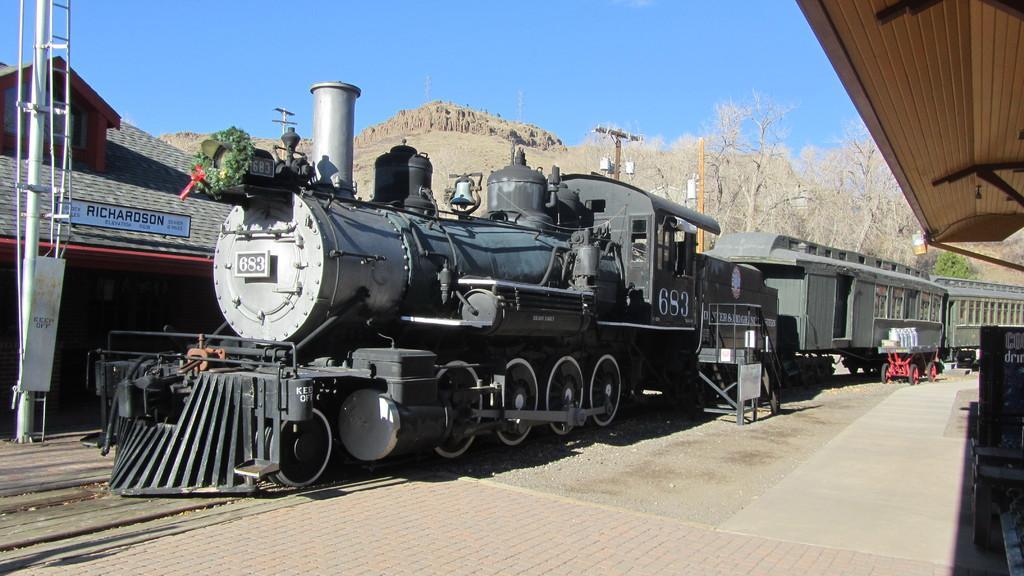Please provide a concise description of this image. In this picture there is a train on the track and there are trees and a mountain in the background. 